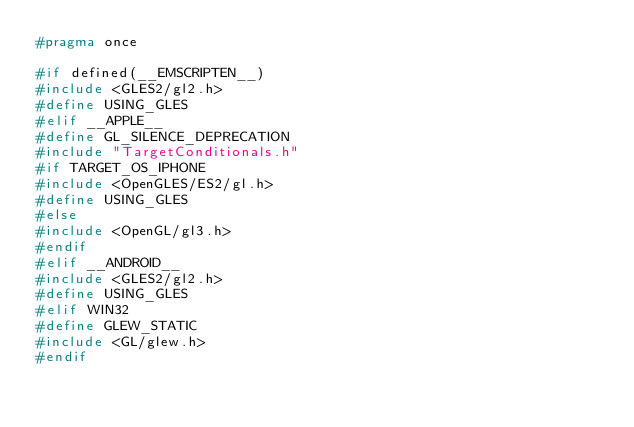<code> <loc_0><loc_0><loc_500><loc_500><_C++_>#pragma once

#if defined(__EMSCRIPTEN__)
#include <GLES2/gl2.h>
#define USING_GLES
#elif __APPLE__
#define GL_SILENCE_DEPRECATION
#include "TargetConditionals.h"
#if TARGET_OS_IPHONE
#include <OpenGLES/ES2/gl.h>
#define USING_GLES
#else
#include <OpenGL/gl3.h>
#endif
#elif __ANDROID__
#include <GLES2/gl2.h>
#define USING_GLES
#elif WIN32
#define GLEW_STATIC
#include <GL/glew.h>
#endif
</code> 